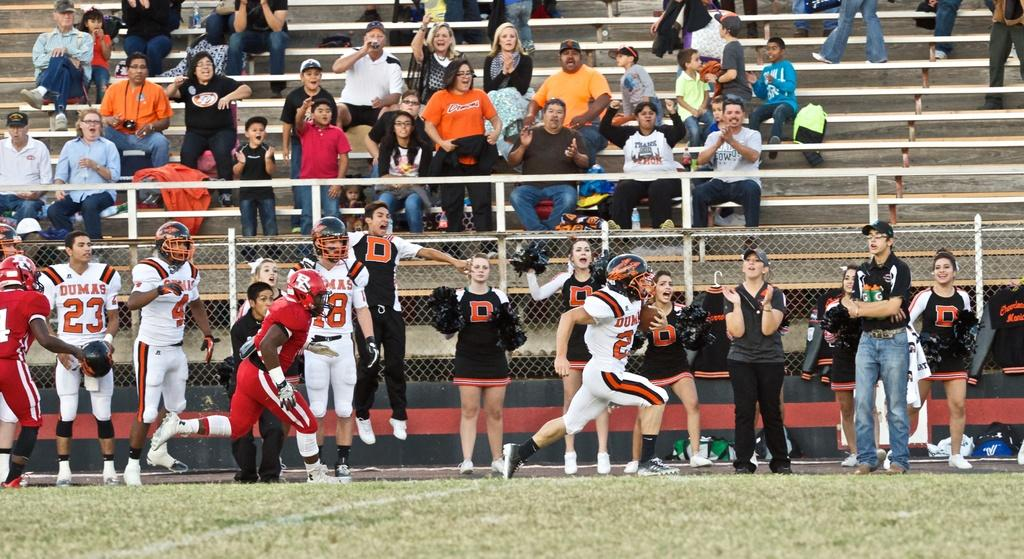What are the people in the image doing on the staircase? There are people sitting and standing on the staircase in the image. What else can be seen in the image besides the staircase? There are fences in the image. What are the people on the ground doing? There are people standing and running on the ground in the image. What type of sign can be seen warning people about the presence of dinosaurs in the image? There is no sign present in the image, and there are no dinosaurs depicted either. What is the weather like in the image? The provided facts do not mention the weather, so it cannot be determined from the image. 